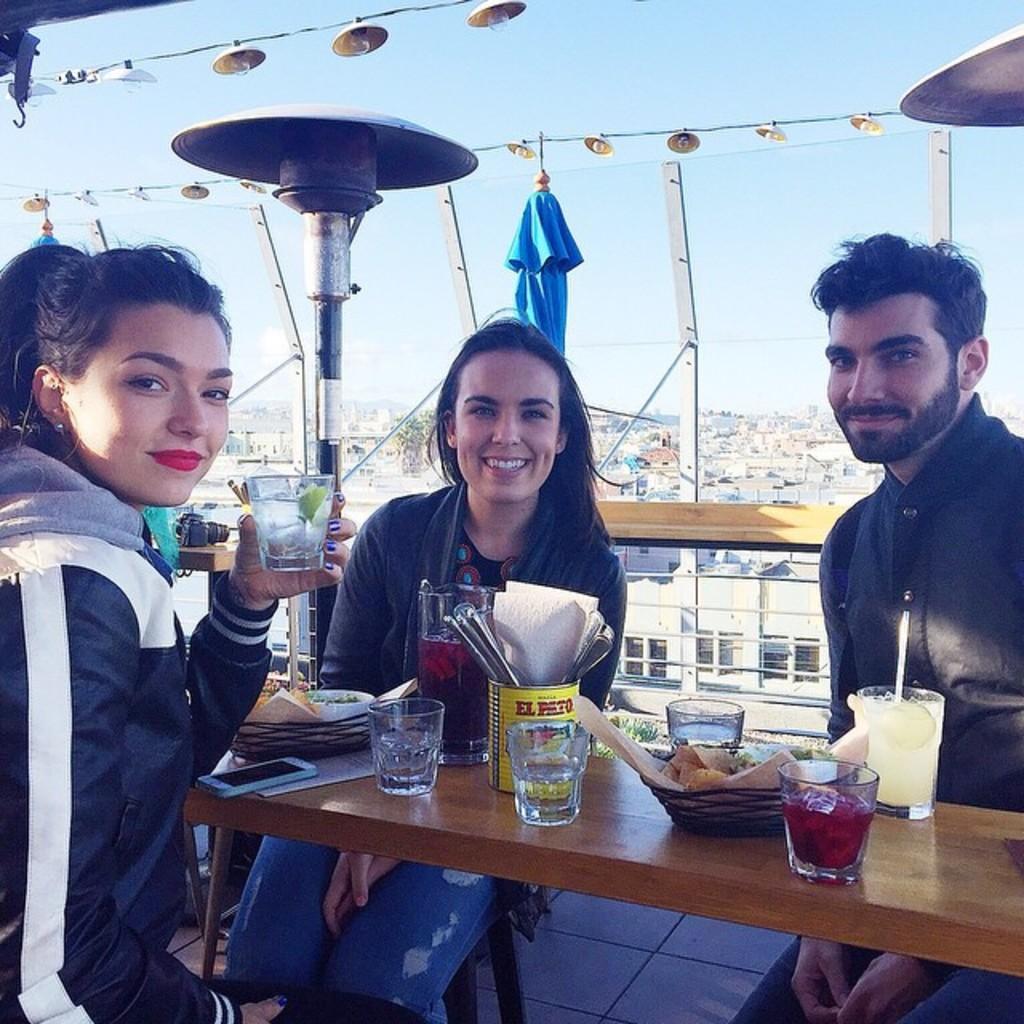In one or two sentences, can you explain what this image depicts? We can see 3 people sitting on chairs with table in front of them and there are mocktails present on the table and all of them or smiling 